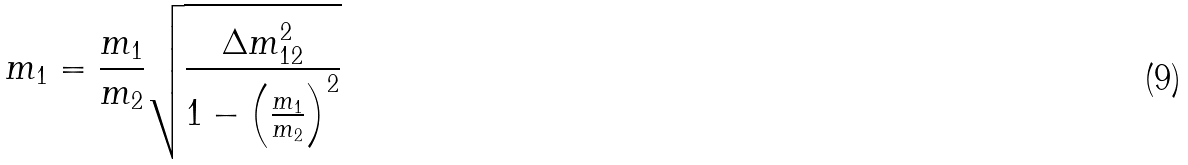Convert formula to latex. <formula><loc_0><loc_0><loc_500><loc_500>m _ { 1 } = \frac { m _ { 1 } } { m _ { 2 } } \sqrt { \frac { \Delta m _ { 1 2 } ^ { 2 } } { 1 - \left ( \frac { m _ { 1 } } { m _ { 2 } } \right ) ^ { 2 } } }</formula> 